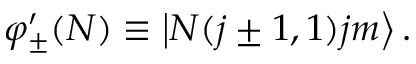<formula> <loc_0><loc_0><loc_500><loc_500>\varphi _ { \pm } ^ { \prime } ( N ) \equiv \left | N ( j \pm 1 , 1 ) j m \right \rangle .</formula> 